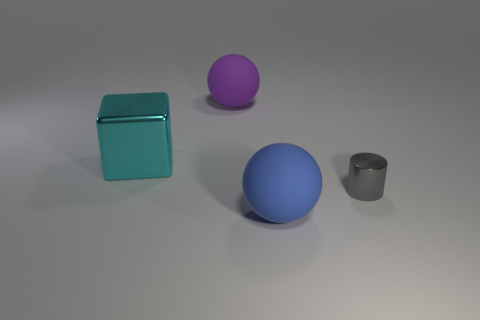Does the shiny object on the right side of the large cube have the same shape as the matte thing behind the large blue rubber sphere?
Offer a terse response. No. Is there a large blue object made of the same material as the cyan block?
Keep it short and to the point. No. There is a ball that is in front of the rubber sphere that is behind the shiny thing that is to the left of the small thing; what color is it?
Keep it short and to the point. Blue. Do the object right of the large blue ball and the big sphere behind the small gray metallic cylinder have the same material?
Make the answer very short. No. There is a metal thing in front of the block; what is its shape?
Make the answer very short. Cylinder. What number of objects are large brown matte objects or things that are in front of the purple rubber thing?
Offer a very short reply. 3. Are the purple thing and the blue object made of the same material?
Your response must be concise. Yes. Is the number of large rubber things in front of the purple rubber sphere the same as the number of purple matte objects that are on the left side of the big blue matte object?
Your response must be concise. Yes. How many big blue rubber spheres are left of the tiny gray cylinder?
Keep it short and to the point. 1. What number of things are either large purple metal objects or tiny gray cylinders?
Provide a succinct answer. 1. 